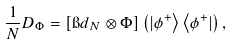<formula> <loc_0><loc_0><loc_500><loc_500>\frac { 1 } { N } D _ { \Phi } = [ \i d _ { N } \otimes \Phi ] \left ( | \phi ^ { + } \right \rangle \left \langle \phi ^ { + } | \right ) ,</formula> 